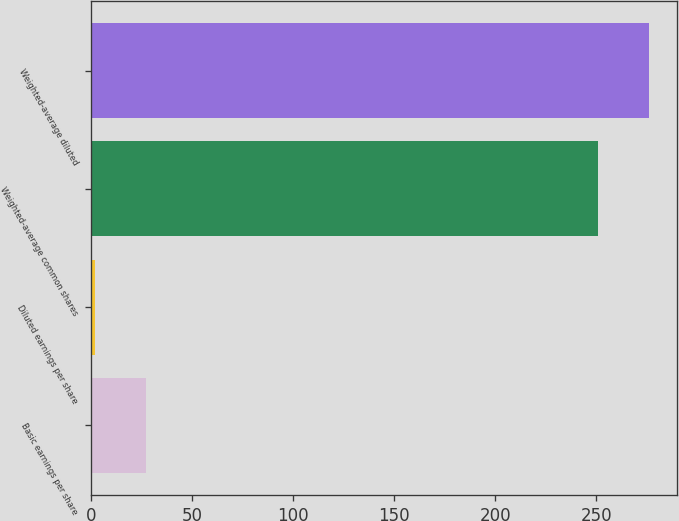<chart> <loc_0><loc_0><loc_500><loc_500><bar_chart><fcel>Basic earnings per share<fcel>Diluted earnings per share<fcel>Weighted-average common shares<fcel>Weighted-average diluted<nl><fcel>27.16<fcel>1.88<fcel>250.8<fcel>276.08<nl></chart> 